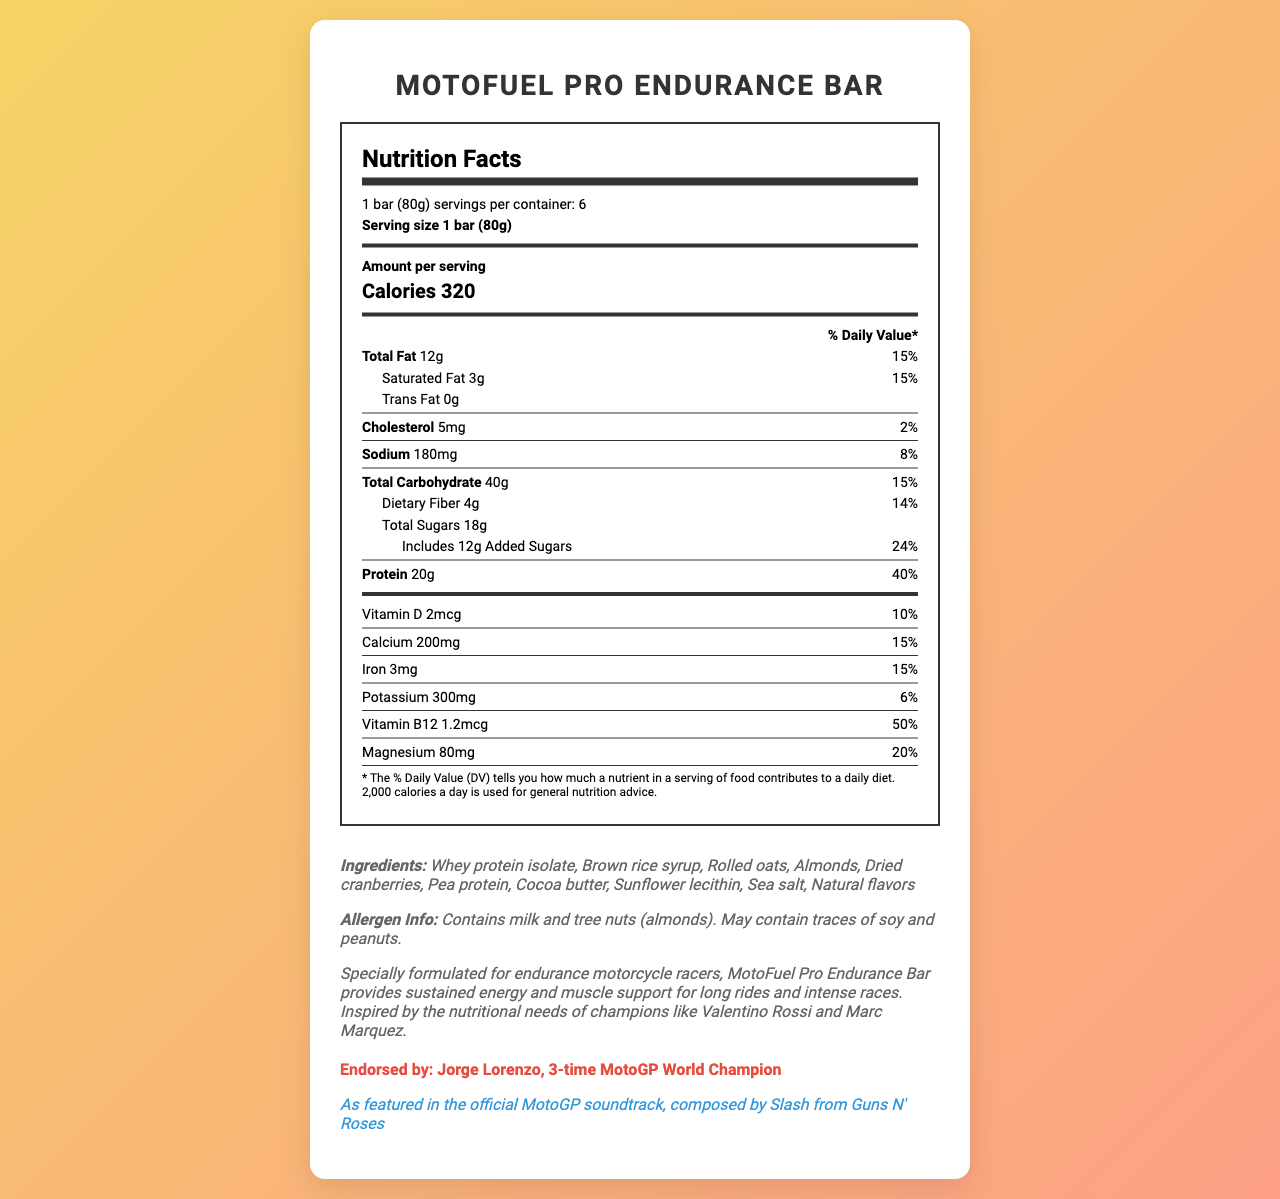what is the serving size of the MotoFuel Pro Endurance Bar? The serving size is listed right at the top under the "Nutrition Facts" section.
Answer: 1 bar (80g) how many calories does one serving contain? The calorie count is displayed prominently right below the "Amount per serving" section, marked in bold for easy identification.
Answer: 320 calories what percentage of the daily value of protein does one bar provide? This information is listed in the "Protein" section, showing "20g of protein" and "40% daily value."
Answer: 40% what ingredients are used in the MotoFuel Pro Endurance Bar? The ingredients are listed in the "Ingredients" section of the document.
Answer: Whey protein isolate, Brown rice syrup, Rolled oats, Almonds, Dried cranberries, Pea protein, Cocoa butter, Sunflower lecithin, Sea salt, Natural flavors how many grams of dietary fiber are in one serving? This detail is found under the "Total Carbohydrate" section, specifically in the sub-section for "Dietary Fiber."
Answer: 4g which nutrient is present in the highest amount per daily value percentage? A. Vitamin C B. Vitamin B12 C. Protein D. Calcium Based on the daily value percentages listed for each nutrient, Vitamin B12 is present at 50%, which is the highest.
Answer: B. Vitamin B12 which of the following elements is not listed in the MotoFuel Pro Endurance Bar ingredients? A. Whey protein isolate B. Soy C. Almonds D. Pea protein The ingredients list mentions whey protein isolate, almonds, and pea protein, but soy is only mentioned in the allergen information as a possible trace and not an actual ingredient in the bar.
Answer: B. Soy does the MotoFuel Pro Endurance Bar contain any trans fat? The document states "Trans Fat 0g" under the "Total Fat" section.
Answer: No who endorses the MotoFuel Pro Endurance Bar? The endorsement can be found towards the bottom, indicating Jorge Lorenzo, a 3-time MotoGP World Champion, endorses this product.
Answer: Jorge Lorenzo what is the primary theme of the nutrition label for the MotoFuel Pro Endurance Bar? The document includes a nutrition facts label, list of ingredients, allergen information, a product description, endorsement details, and a music connection, all tailored for motorcycle racers looking for a high-energy protein bar.
Answer: The document provides detailed nutritional information for the MotoFuel Pro Endurance Bar, highlighting its high protein content, essential vitamins and minerals, and its suitability for endurance motorcycle racers. what is the source of all the sugars in the MotoFuel Pro Endurance Bar? The document specifies the total sugars and added sugars but does not provide detailed sources.
Answer: Not enough information does the motorcycle racing connection enhance the marketing of the MotoFuel Pro Endurance Bar? The document describes the product as specially formulated for endurance motorcycle racers and is endorsed by a famous racer, which enhances its appeal to the target market.
Answer: Yes 